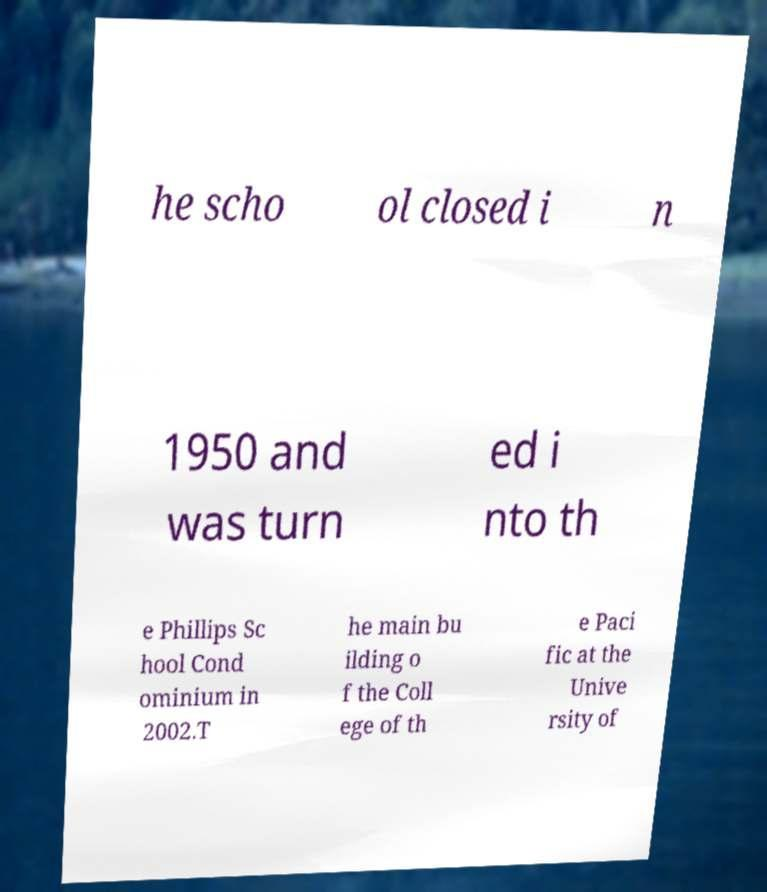Can you accurately transcribe the text from the provided image for me? he scho ol closed i n 1950 and was turn ed i nto th e Phillips Sc hool Cond ominium in 2002.T he main bu ilding o f the Coll ege of th e Paci fic at the Unive rsity of 